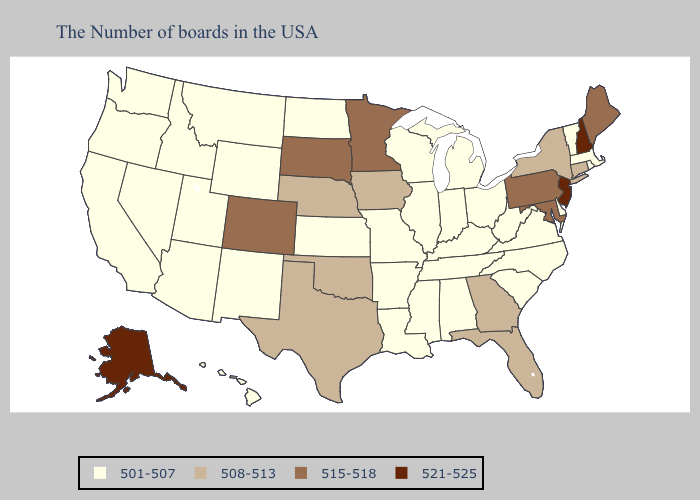What is the highest value in states that border Mississippi?
Give a very brief answer. 501-507. Does New York have the lowest value in the USA?
Give a very brief answer. No. Which states have the lowest value in the USA?
Keep it brief. Massachusetts, Rhode Island, Vermont, Delaware, Virginia, North Carolina, South Carolina, West Virginia, Ohio, Michigan, Kentucky, Indiana, Alabama, Tennessee, Wisconsin, Illinois, Mississippi, Louisiana, Missouri, Arkansas, Kansas, North Dakota, Wyoming, New Mexico, Utah, Montana, Arizona, Idaho, Nevada, California, Washington, Oregon, Hawaii. Does Utah have a higher value than Montana?
Quick response, please. No. Which states have the lowest value in the USA?
Short answer required. Massachusetts, Rhode Island, Vermont, Delaware, Virginia, North Carolina, South Carolina, West Virginia, Ohio, Michigan, Kentucky, Indiana, Alabama, Tennessee, Wisconsin, Illinois, Mississippi, Louisiana, Missouri, Arkansas, Kansas, North Dakota, Wyoming, New Mexico, Utah, Montana, Arizona, Idaho, Nevada, California, Washington, Oregon, Hawaii. Among the states that border Missouri , does Nebraska have the highest value?
Concise answer only. Yes. What is the value of Tennessee?
Short answer required. 501-507. Does Alaska have the highest value in the USA?
Answer briefly. Yes. What is the highest value in the USA?
Write a very short answer. 521-525. What is the value of Illinois?
Write a very short answer. 501-507. Does the map have missing data?
Quick response, please. No. Does Virginia have the lowest value in the USA?
Give a very brief answer. Yes. What is the highest value in the USA?
Be succinct. 521-525. What is the highest value in the Northeast ?
Be succinct. 521-525. What is the value of West Virginia?
Be succinct. 501-507. 